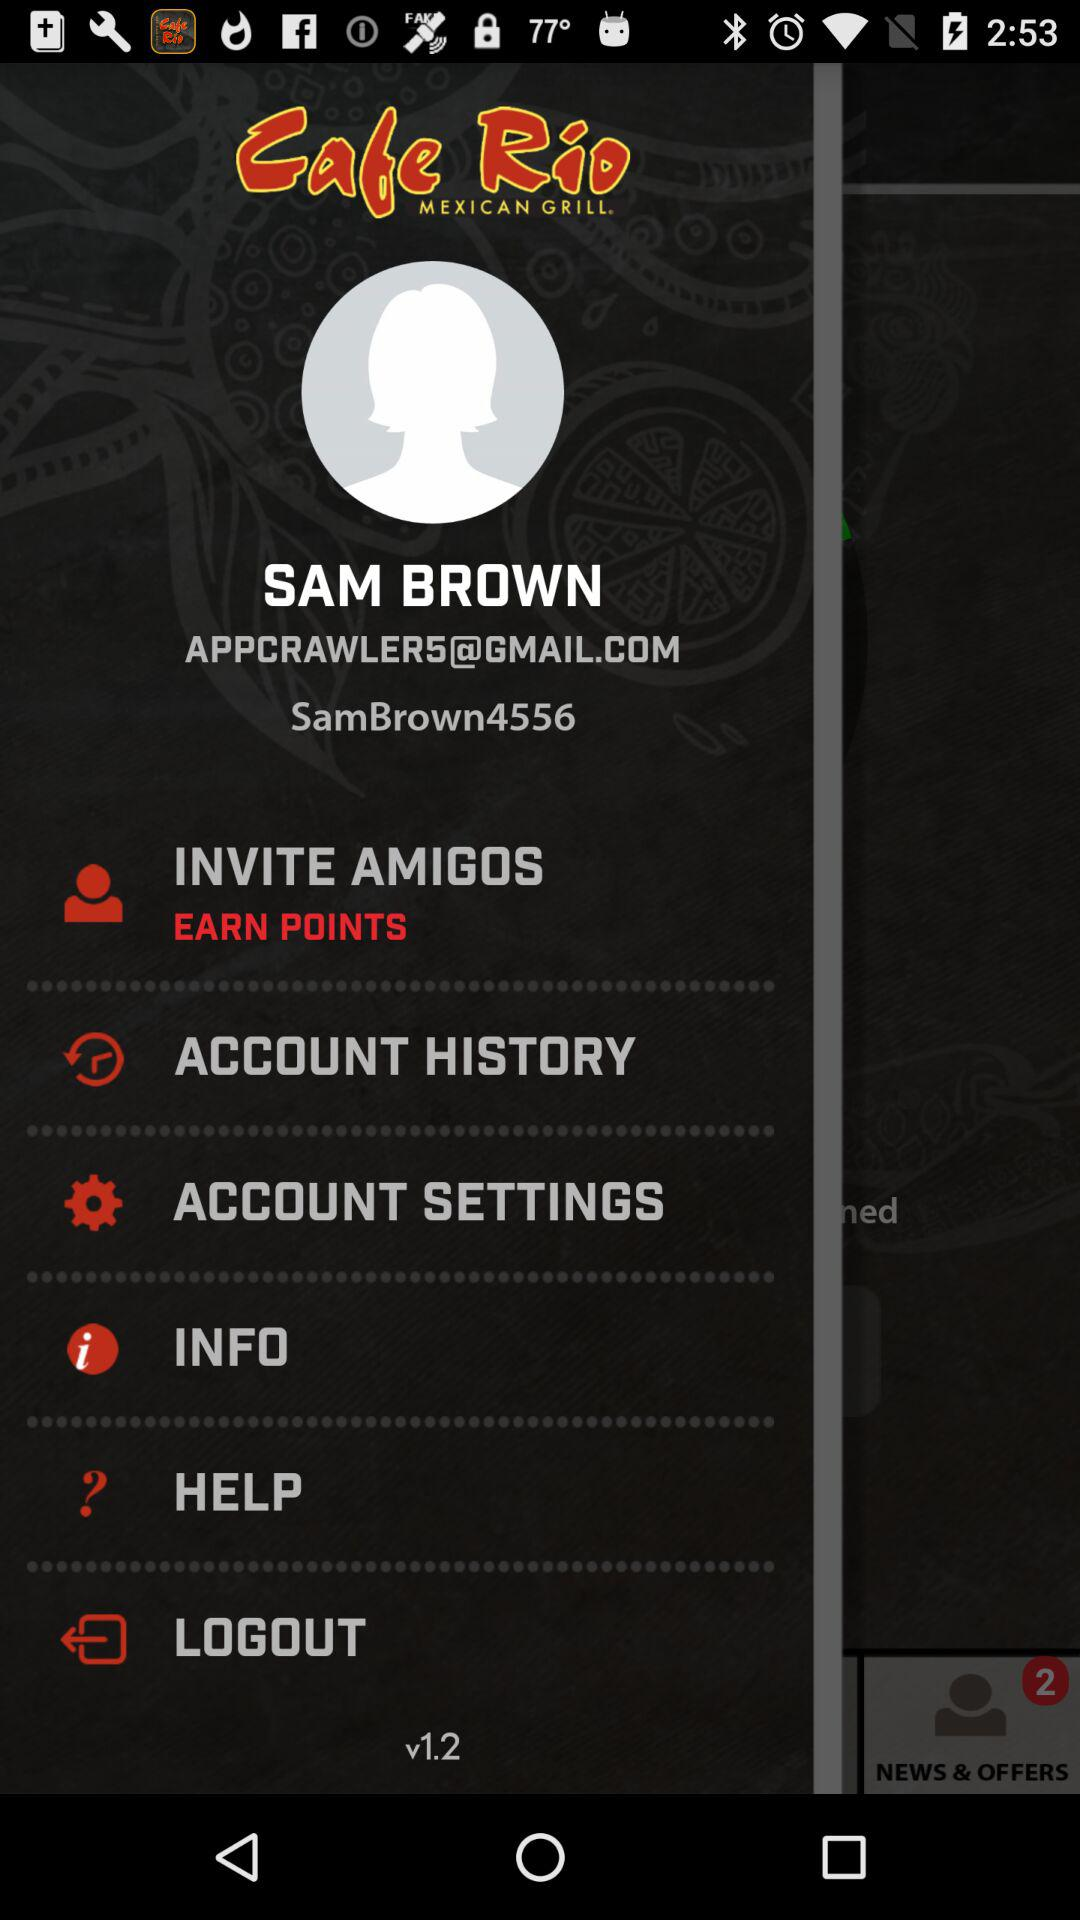What is the email address? The email address is APPCRAWLERS@GMAIL.COM. 